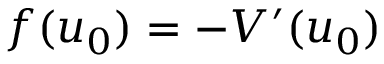<formula> <loc_0><loc_0><loc_500><loc_500>f ( u _ { 0 } ) = - V ^ { \prime } ( u _ { 0 } )</formula> 